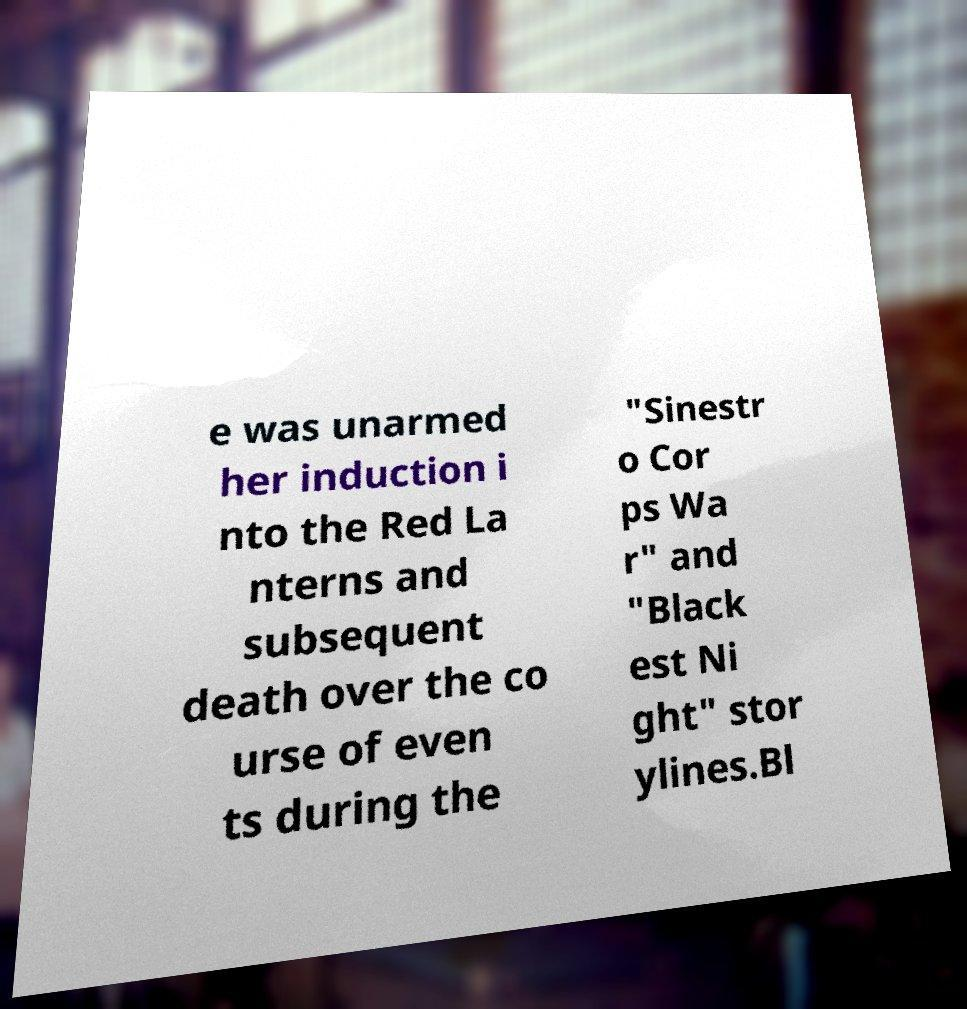There's text embedded in this image that I need extracted. Can you transcribe it verbatim? e was unarmed her induction i nto the Red La nterns and subsequent death over the co urse of even ts during the "Sinestr o Cor ps Wa r" and "Black est Ni ght" stor ylines.Bl 